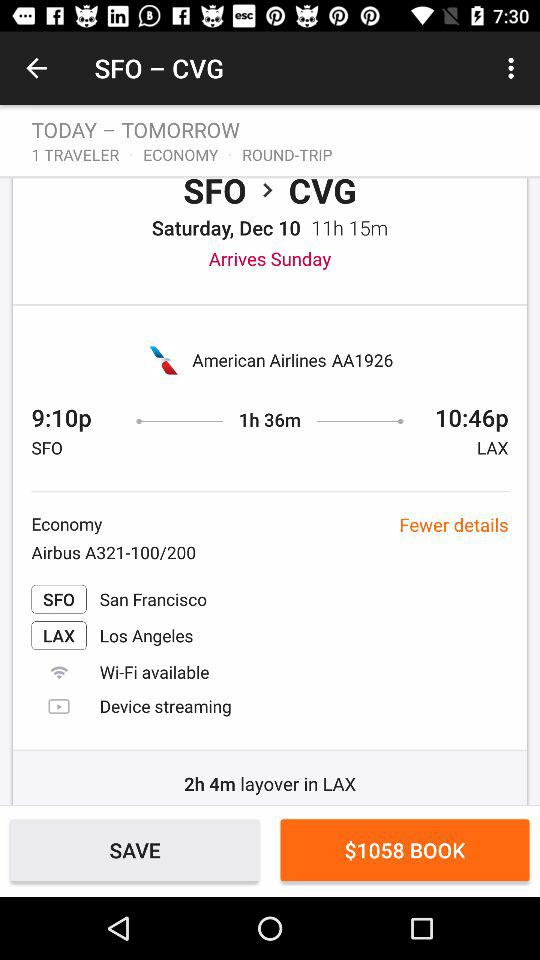What airline is the ticket booked on? The ticket is booked on "American Airlines". 